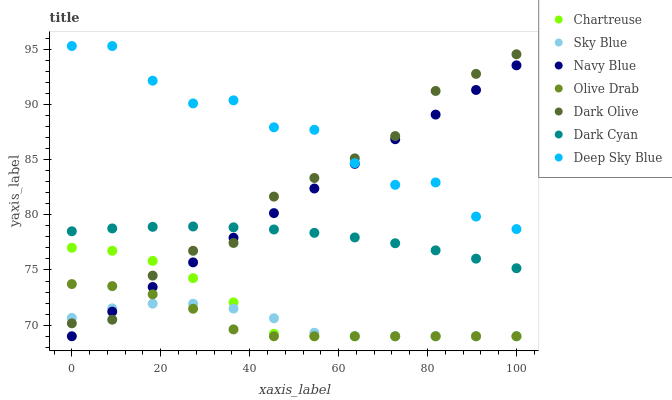Does Sky Blue have the minimum area under the curve?
Answer yes or no. Yes. Does Deep Sky Blue have the maximum area under the curve?
Answer yes or no. Yes. Does Dark Olive have the minimum area under the curve?
Answer yes or no. No. Does Dark Olive have the maximum area under the curve?
Answer yes or no. No. Is Navy Blue the smoothest?
Answer yes or no. Yes. Is Deep Sky Blue the roughest?
Answer yes or no. Yes. Is Dark Olive the smoothest?
Answer yes or no. No. Is Dark Olive the roughest?
Answer yes or no. No. Does Navy Blue have the lowest value?
Answer yes or no. Yes. Does Dark Olive have the lowest value?
Answer yes or no. No. Does Deep Sky Blue have the highest value?
Answer yes or no. Yes. Does Dark Olive have the highest value?
Answer yes or no. No. Is Dark Cyan less than Deep Sky Blue?
Answer yes or no. Yes. Is Dark Cyan greater than Olive Drab?
Answer yes or no. Yes. Does Chartreuse intersect Navy Blue?
Answer yes or no. Yes. Is Chartreuse less than Navy Blue?
Answer yes or no. No. Is Chartreuse greater than Navy Blue?
Answer yes or no. No. Does Dark Cyan intersect Deep Sky Blue?
Answer yes or no. No. 